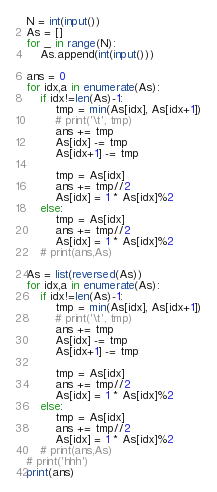<code> <loc_0><loc_0><loc_500><loc_500><_Python_>N = int(input())
As = []
for _ in range(N):
    As.append(int(input()))

ans = 0
for idx,a in enumerate(As):
    if idx!=len(As)-1:
        tmp = min(As[idx], As[idx+1])
        # print('\t', tmp)
        ans += tmp
        As[idx] -= tmp
        As[idx+1] -= tmp

        tmp = As[idx]
        ans += tmp//2
        As[idx] = 1 * As[idx]%2
    else:
        tmp = As[idx]
        ans += tmp//2
        As[idx] = 1 * As[idx]%2
    # print(ans,As)

As = list(reversed(As))
for idx,a in enumerate(As):
    if idx!=len(As)-1:
        tmp = min(As[idx], As[idx+1])
        # print('\t', tmp)
        ans += tmp
        As[idx] -= tmp
        As[idx+1] -= tmp

        tmp = As[idx]
        ans += tmp//2
        As[idx] = 1 * As[idx]%2
    else:
        tmp = As[idx]
        ans += tmp//2
        As[idx] = 1 * As[idx]%2
    # print(ans,As)
# print('hhh')
print(ans)
</code> 